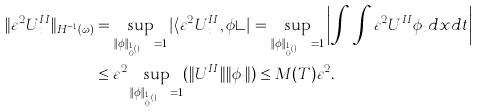Convert formula to latex. <formula><loc_0><loc_0><loc_500><loc_500>\| \varepsilon ^ { 2 } U ^ { I I } _ { t } \| _ { H ^ { - 1 } ( \omega ) } & = \sup _ { \| \phi \| _ { H ^ { 1 } _ { 0 } ( \omega ) } = 1 } | \langle \varepsilon ^ { 2 } U ^ { I I } _ { t } , \phi \rangle | = \sup _ { \| \phi \| _ { H ^ { 1 } _ { 0 } ( \omega ) } = 1 } \left | \int \, \int \varepsilon ^ { 2 } U ^ { I I } \phi _ { t } d x d t \right | \\ & \leq \varepsilon ^ { 2 } \sup _ { \| \phi \| _ { H ^ { 1 } _ { 0 } ( \omega ) } = 1 } ( \| U ^ { I I } \| \| \phi _ { t } \| ) \leq M ( T ) \varepsilon ^ { 2 } .</formula> 